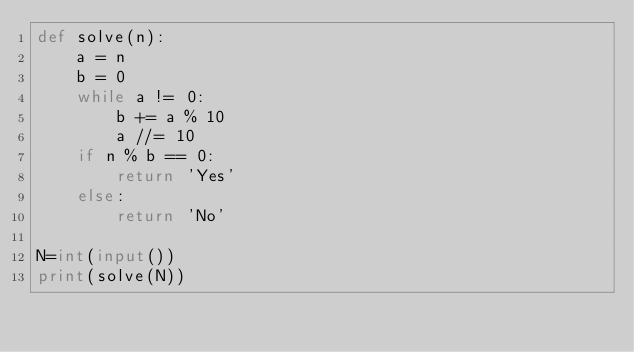<code> <loc_0><loc_0><loc_500><loc_500><_Python_>def solve(n):
    a = n
    b = 0
    while a != 0:
        b += a % 10
        a //= 10
    if n % b == 0:
        return 'Yes'
    else:
        return 'No'

N=int(input())
print(solve(N))
</code> 